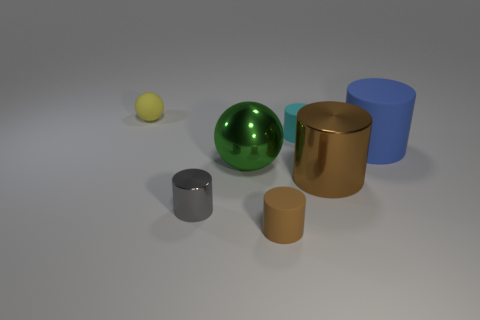Subtract all blue matte cylinders. How many cylinders are left? 4 Subtract all blue cylinders. How many cylinders are left? 4 Subtract all yellow cylinders. Subtract all green spheres. How many cylinders are left? 5 Add 1 big gray objects. How many objects exist? 8 Subtract all balls. How many objects are left? 5 Subtract 0 red blocks. How many objects are left? 7 Subtract all metal cylinders. Subtract all blue rubber things. How many objects are left? 4 Add 7 large shiny cylinders. How many large shiny cylinders are left? 8 Add 6 small metallic objects. How many small metallic objects exist? 7 